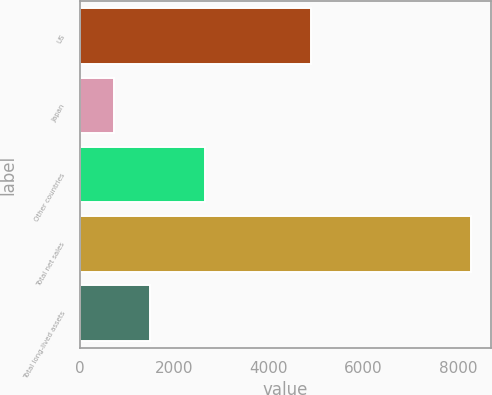Convert chart. <chart><loc_0><loc_0><loc_500><loc_500><bar_chart><fcel>US<fcel>Japan<fcel>Other countries<fcel>Total net sales<fcel>Total long-lived assets<nl><fcel>4893<fcel>738<fcel>2648<fcel>8279<fcel>1492.1<nl></chart> 